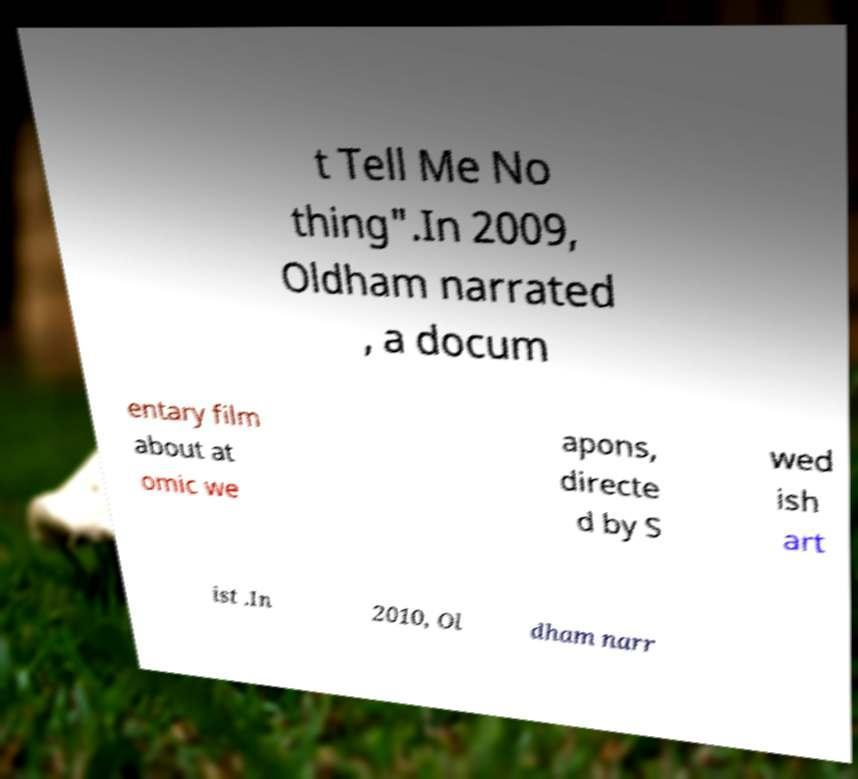Please read and relay the text visible in this image. What does it say? t Tell Me No thing".In 2009, Oldham narrated , a docum entary film about at omic we apons, directe d by S wed ish art ist .In 2010, Ol dham narr 